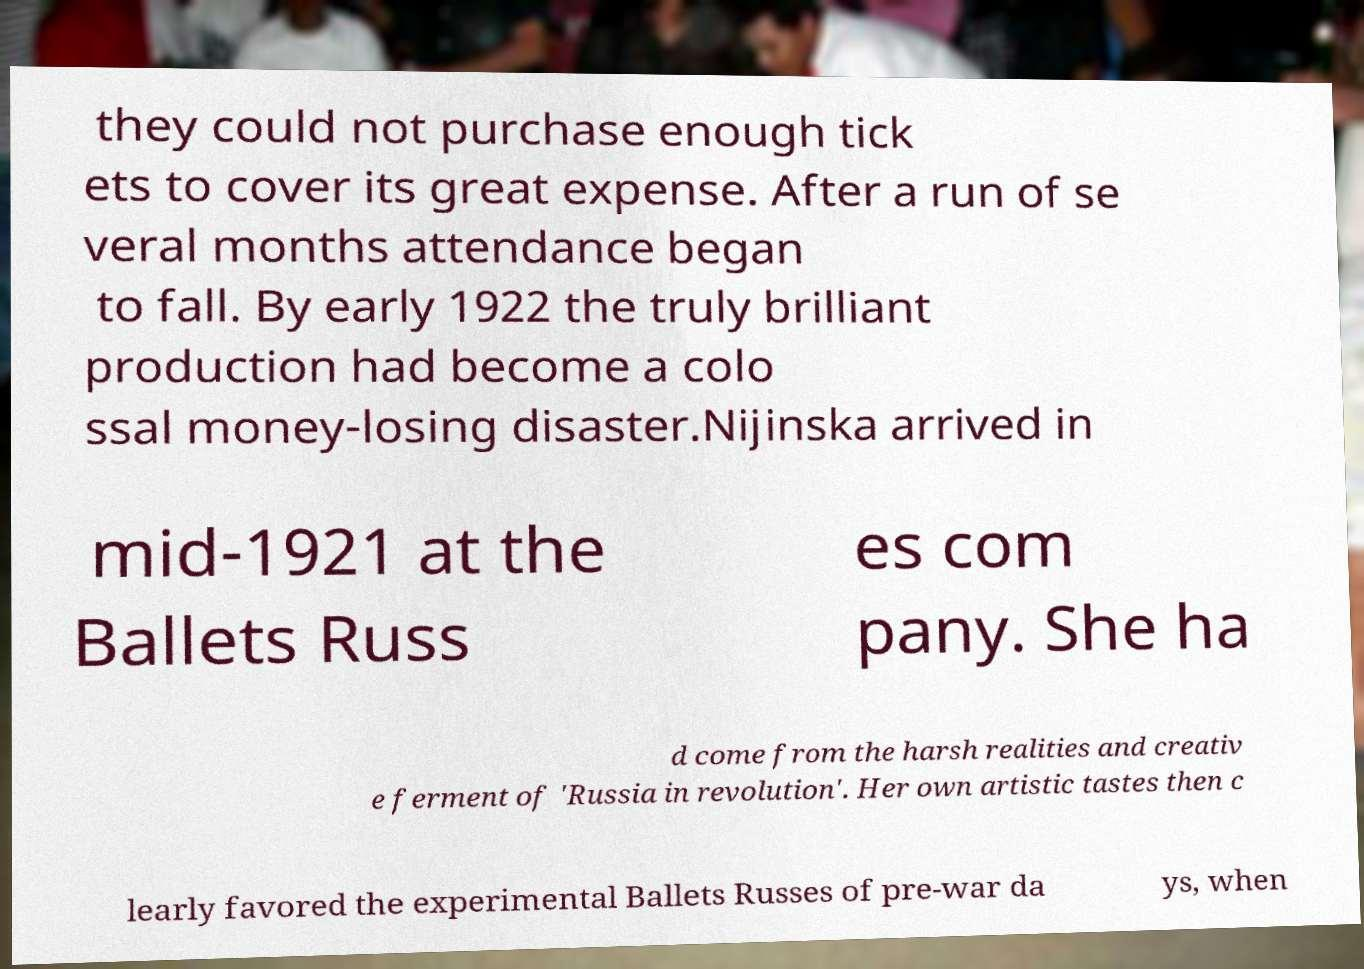Can you accurately transcribe the text from the provided image for me? they could not purchase enough tick ets to cover its great expense. After a run of se veral months attendance began to fall. By early 1922 the truly brilliant production had become a colo ssal money-losing disaster.Nijinska arrived in mid-1921 at the Ballets Russ es com pany. She ha d come from the harsh realities and creativ e ferment of 'Russia in revolution'. Her own artistic tastes then c learly favored the experimental Ballets Russes of pre-war da ys, when 